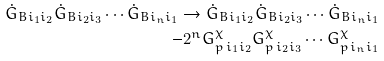Convert formula to latex. <formula><loc_0><loc_0><loc_500><loc_500>\dot { G } _ { B i _ { 1 } i _ { 2 } } \dot { G } _ { B i _ { 2 } i _ { 3 } } \cdots \dot { G } _ { B i _ { n } i _ { 1 } } \rightarrow \dot { G } _ { B i _ { 1 } i _ { 2 } } \dot { G } _ { B i _ { 2 } i _ { 3 } } \cdots \dot { G } _ { B i _ { n } i _ { 1 } } \\ - 2 ^ { n } { G } ^ { \chi } _ { p \, i _ { 1 } i _ { 2 } } { G } ^ { \chi } _ { p \, i _ { 2 } i _ { 3 } } \cdots { G } ^ { \chi } _ { p \, i _ { n } i _ { 1 } } \\</formula> 